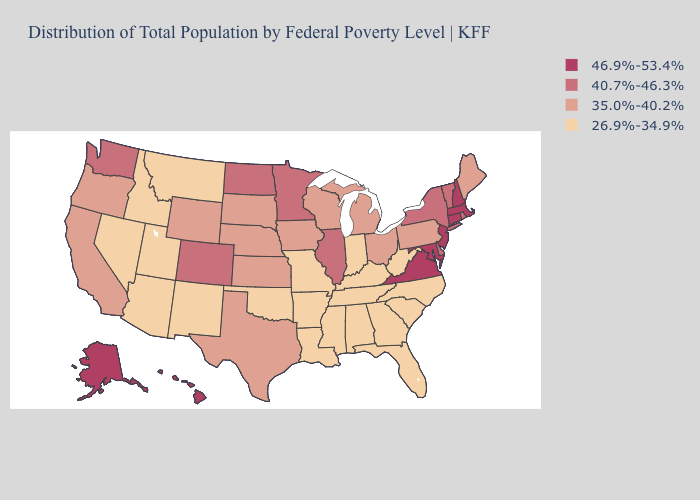How many symbols are there in the legend?
Answer briefly. 4. What is the lowest value in the West?
Quick response, please. 26.9%-34.9%. Name the states that have a value in the range 40.7%-46.3%?
Short answer required. Colorado, Delaware, Illinois, Minnesota, New York, North Dakota, Rhode Island, Vermont, Washington. Name the states that have a value in the range 35.0%-40.2%?
Keep it brief. California, Iowa, Kansas, Maine, Michigan, Nebraska, Ohio, Oregon, Pennsylvania, South Dakota, Texas, Wisconsin, Wyoming. Does Michigan have a higher value than Louisiana?
Be succinct. Yes. Among the states that border Massachusetts , does New Hampshire have the lowest value?
Keep it brief. No. What is the value of Arizona?
Keep it brief. 26.9%-34.9%. Does Massachusetts have the lowest value in the USA?
Concise answer only. No. What is the value of Florida?
Concise answer only. 26.9%-34.9%. What is the lowest value in states that border Ohio?
Concise answer only. 26.9%-34.9%. What is the value of Maine?
Be succinct. 35.0%-40.2%. What is the value of Florida?
Concise answer only. 26.9%-34.9%. What is the highest value in the USA?
Be succinct. 46.9%-53.4%. Which states have the lowest value in the USA?
Give a very brief answer. Alabama, Arizona, Arkansas, Florida, Georgia, Idaho, Indiana, Kentucky, Louisiana, Mississippi, Missouri, Montana, Nevada, New Mexico, North Carolina, Oklahoma, South Carolina, Tennessee, Utah, West Virginia. 